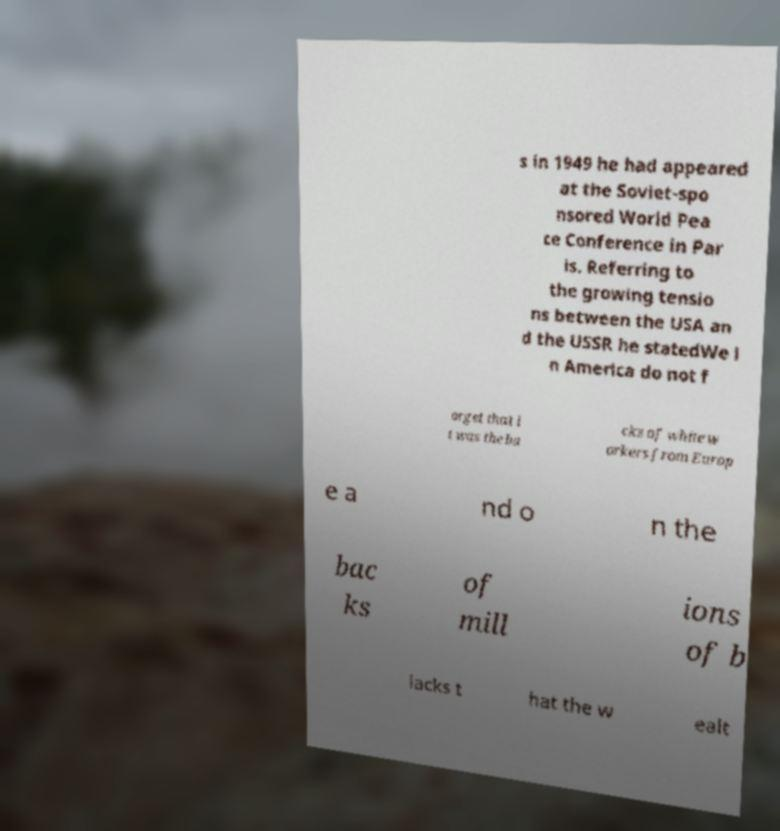Can you accurately transcribe the text from the provided image for me? s in 1949 he had appeared at the Soviet-spo nsored World Pea ce Conference in Par is. Referring to the growing tensio ns between the USA an d the USSR he statedWe i n America do not f orget that i t was the ba cks of white w orkers from Europ e a nd o n the bac ks of mill ions of b lacks t hat the w ealt 